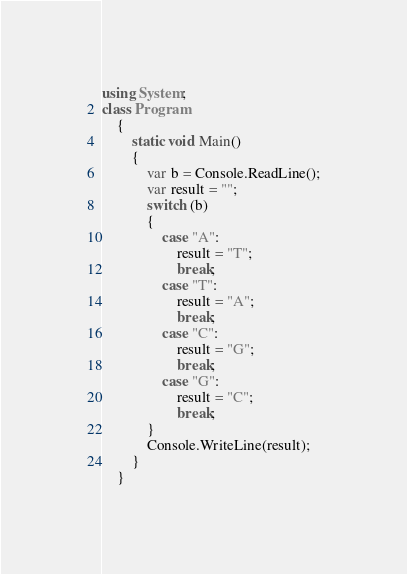<code> <loc_0><loc_0><loc_500><loc_500><_C#_>using System;
class Program
    {
        static void Main()
        {
            var b = Console.ReadLine();
            var result = "";
            switch (b)
            {
                case "A":
                    result = "T";
                    break;
                case "T":
                    result = "A";
                    break;
                case "C":
                    result = "G";
                    break;
                case "G":
                    result = "C";
                    break;
            }
            Console.WriteLine(result);
        }
    }</code> 